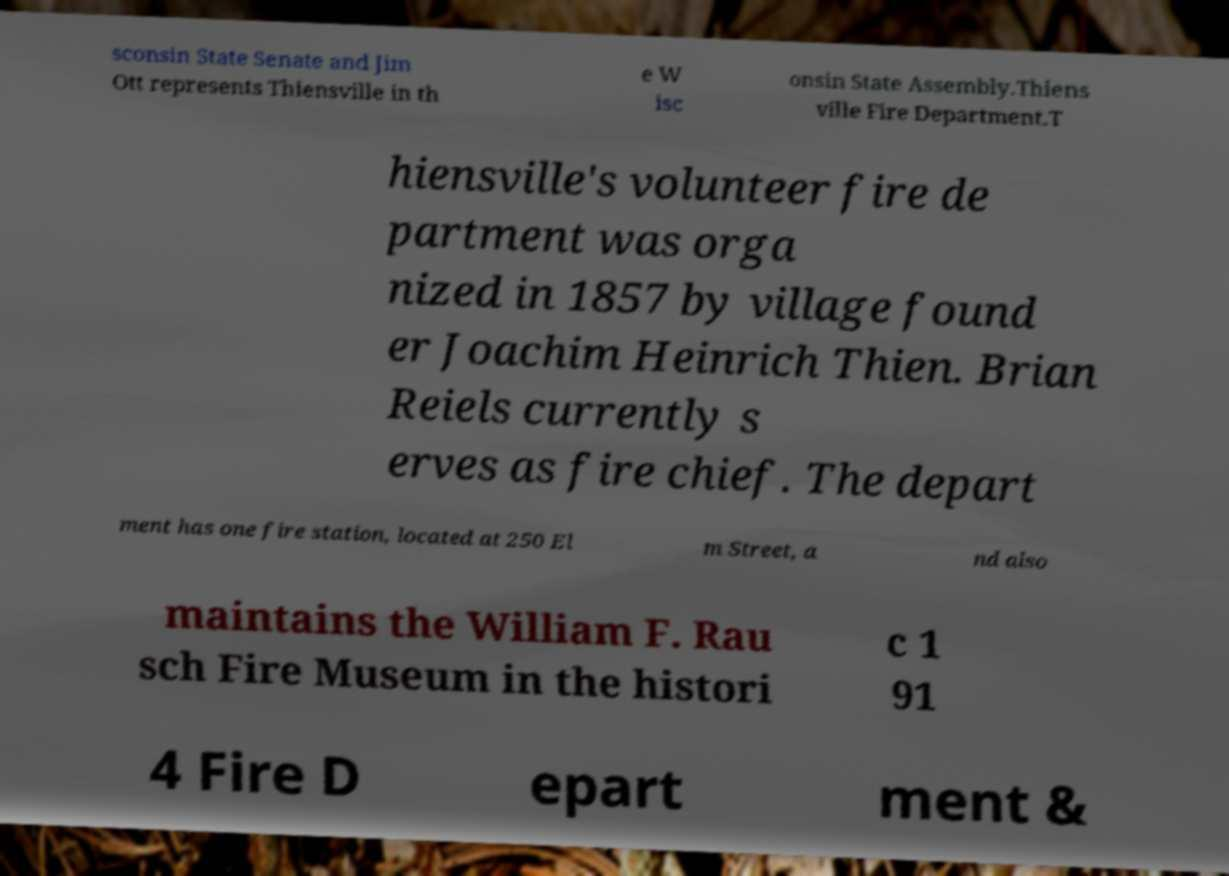Please read and relay the text visible in this image. What does it say? sconsin State Senate and Jim Ott represents Thiensville in th e W isc onsin State Assembly.Thiens ville Fire Department.T hiensville's volunteer fire de partment was orga nized in 1857 by village found er Joachim Heinrich Thien. Brian Reiels currently s erves as fire chief. The depart ment has one fire station, located at 250 El m Street, a nd also maintains the William F. Rau sch Fire Museum in the histori c 1 91 4 Fire D epart ment & 